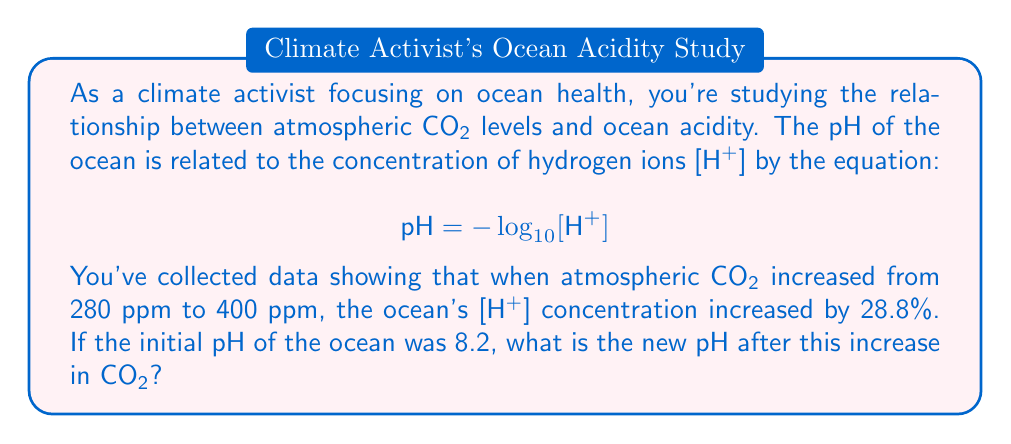Can you solve this math problem? Let's approach this step-by-step:

1) First, we need to find the initial [H⁺] concentration. We can use the given pH equation:

   $8.2 = -\log_{10}[\text{H}^+]_{\text{initial}}$

2) Solve for [H⁺]initial:
   
   $[\text{H}^+]_{\text{initial}} = 10^{-8.2} \approx 6.31 \times 10^{-9} \text{ mol/L}$

3) Now, we're told that [H⁺] increased by 28.8%. To calculate the new [H⁺]:

   $[\text{H}^+]_{\text{new}} = [\text{H}^+]_{\text{initial}} \times (1 + 0.288)$
   $= (6.31 \times 10^{-9}) \times 1.288$
   $\approx 8.13 \times 10^{-9} \text{ mol/L}$

4) To find the new pH, we use the pH equation again:

   $\text{pH}_{\text{new}} = -\log_{10}[\text{H}^+]_{\text{new}}$
   $= -\log_{10}(8.13 \times 10^{-9})$
   $\approx 8.09$

Thus, the new pH of the ocean after the increase in CO₂ is approximately 8.09.
Answer: The new pH of the ocean is approximately 8.09. 